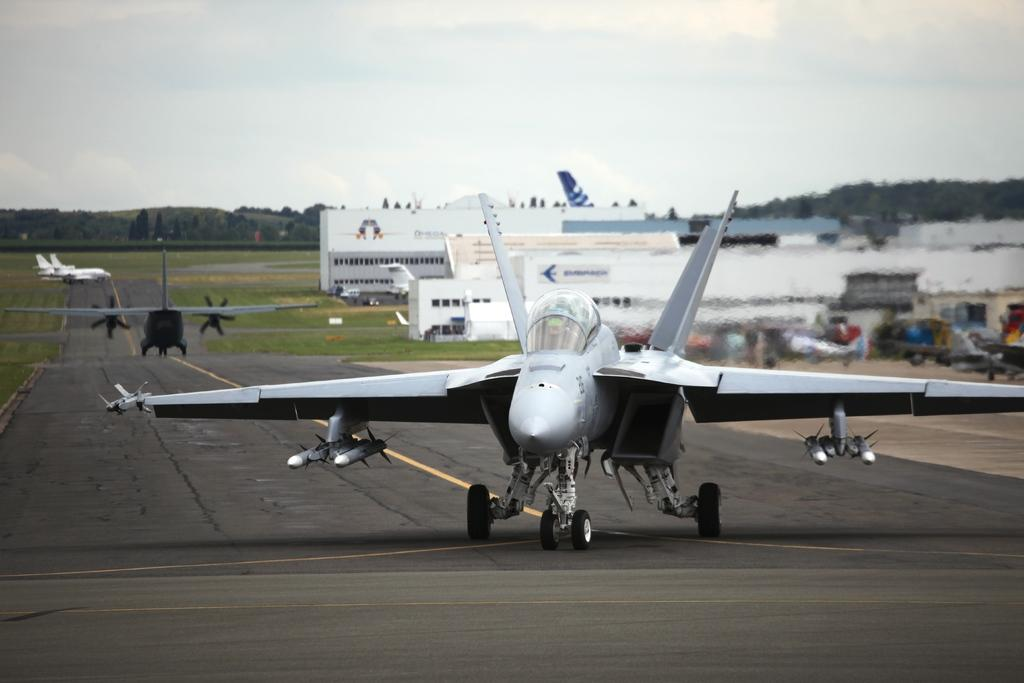What is the main subject of the image? The main subject of the image is aircraft on a runway. What can be seen in the background of the image? In the background of the image, there are buildings, trees, a mountain, and the sky. How many aircraft are visible on the runway? The number of aircraft visible on the runway is not specified in the facts, so it cannot be determined from the information provided. What type of coach is visible in the image? There is no coach present in the image; it features aircraft on a runway and various background elements. What type of coat is being worn by the mountain in the image? The mountain in the image is not a living being and therefore cannot wear a coat. 